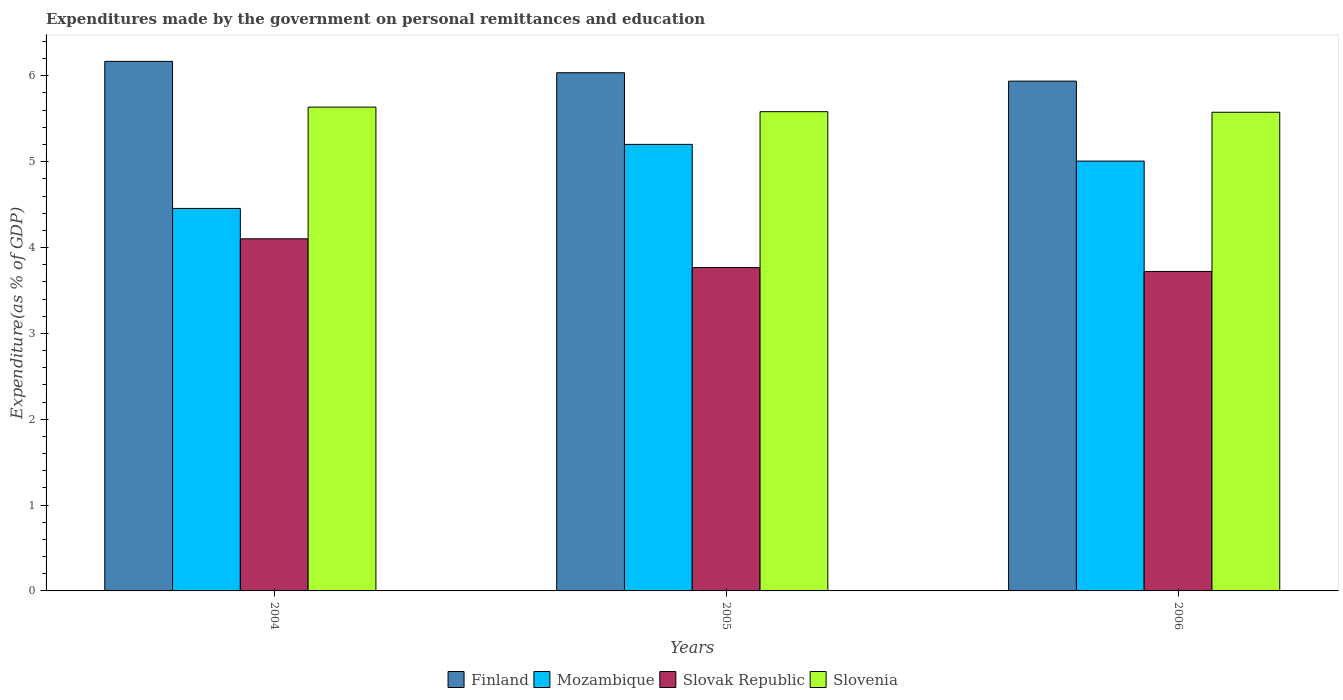How many groups of bars are there?
Your answer should be very brief. 3. How many bars are there on the 2nd tick from the right?
Ensure brevity in your answer.  4. What is the label of the 2nd group of bars from the left?
Give a very brief answer. 2005. In how many cases, is the number of bars for a given year not equal to the number of legend labels?
Provide a succinct answer. 0. What is the expenditures made by the government on personal remittances and education in Mozambique in 2006?
Offer a very short reply. 5.01. Across all years, what is the maximum expenditures made by the government on personal remittances and education in Slovak Republic?
Ensure brevity in your answer.  4.1. Across all years, what is the minimum expenditures made by the government on personal remittances and education in Mozambique?
Provide a short and direct response. 4.46. In which year was the expenditures made by the government on personal remittances and education in Slovak Republic maximum?
Provide a short and direct response. 2004. In which year was the expenditures made by the government on personal remittances and education in Finland minimum?
Ensure brevity in your answer.  2006. What is the total expenditures made by the government on personal remittances and education in Slovak Republic in the graph?
Keep it short and to the point. 11.59. What is the difference between the expenditures made by the government on personal remittances and education in Finland in 2004 and that in 2005?
Ensure brevity in your answer.  0.13. What is the difference between the expenditures made by the government on personal remittances and education in Slovenia in 2006 and the expenditures made by the government on personal remittances and education in Finland in 2004?
Provide a short and direct response. -0.59. What is the average expenditures made by the government on personal remittances and education in Finland per year?
Give a very brief answer. 6.05. In the year 2005, what is the difference between the expenditures made by the government on personal remittances and education in Slovenia and expenditures made by the government on personal remittances and education in Slovak Republic?
Give a very brief answer. 1.82. What is the ratio of the expenditures made by the government on personal remittances and education in Slovenia in 2004 to that in 2005?
Provide a succinct answer. 1.01. Is the difference between the expenditures made by the government on personal remittances and education in Slovenia in 2004 and 2006 greater than the difference between the expenditures made by the government on personal remittances and education in Slovak Republic in 2004 and 2006?
Offer a very short reply. No. What is the difference between the highest and the second highest expenditures made by the government on personal remittances and education in Mozambique?
Keep it short and to the point. 0.19. What is the difference between the highest and the lowest expenditures made by the government on personal remittances and education in Finland?
Provide a short and direct response. 0.23. Is the sum of the expenditures made by the government on personal remittances and education in Finland in 2004 and 2006 greater than the maximum expenditures made by the government on personal remittances and education in Slovenia across all years?
Your response must be concise. Yes. Is it the case that in every year, the sum of the expenditures made by the government on personal remittances and education in Finland and expenditures made by the government on personal remittances and education in Mozambique is greater than the sum of expenditures made by the government on personal remittances and education in Slovak Republic and expenditures made by the government on personal remittances and education in Slovenia?
Ensure brevity in your answer.  Yes. What does the 1st bar from the left in 2004 represents?
Provide a short and direct response. Finland. What does the 2nd bar from the right in 2004 represents?
Give a very brief answer. Slovak Republic. Is it the case that in every year, the sum of the expenditures made by the government on personal remittances and education in Mozambique and expenditures made by the government on personal remittances and education in Slovenia is greater than the expenditures made by the government on personal remittances and education in Finland?
Ensure brevity in your answer.  Yes. Are all the bars in the graph horizontal?
Your answer should be very brief. No. What is the difference between two consecutive major ticks on the Y-axis?
Make the answer very short. 1. How many legend labels are there?
Provide a short and direct response. 4. What is the title of the graph?
Provide a succinct answer. Expenditures made by the government on personal remittances and education. What is the label or title of the Y-axis?
Offer a very short reply. Expenditure(as % of GDP). What is the Expenditure(as % of GDP) of Finland in 2004?
Ensure brevity in your answer.  6.17. What is the Expenditure(as % of GDP) of Mozambique in 2004?
Your response must be concise. 4.46. What is the Expenditure(as % of GDP) in Slovak Republic in 2004?
Your answer should be very brief. 4.1. What is the Expenditure(as % of GDP) of Slovenia in 2004?
Offer a very short reply. 5.64. What is the Expenditure(as % of GDP) of Finland in 2005?
Provide a succinct answer. 6.04. What is the Expenditure(as % of GDP) of Mozambique in 2005?
Your answer should be very brief. 5.2. What is the Expenditure(as % of GDP) of Slovak Republic in 2005?
Your response must be concise. 3.77. What is the Expenditure(as % of GDP) in Slovenia in 2005?
Offer a terse response. 5.58. What is the Expenditure(as % of GDP) in Finland in 2006?
Keep it short and to the point. 5.94. What is the Expenditure(as % of GDP) of Mozambique in 2006?
Offer a terse response. 5.01. What is the Expenditure(as % of GDP) of Slovak Republic in 2006?
Offer a very short reply. 3.72. What is the Expenditure(as % of GDP) in Slovenia in 2006?
Ensure brevity in your answer.  5.58. Across all years, what is the maximum Expenditure(as % of GDP) of Finland?
Provide a succinct answer. 6.17. Across all years, what is the maximum Expenditure(as % of GDP) in Mozambique?
Provide a succinct answer. 5.2. Across all years, what is the maximum Expenditure(as % of GDP) in Slovak Republic?
Keep it short and to the point. 4.1. Across all years, what is the maximum Expenditure(as % of GDP) in Slovenia?
Offer a very short reply. 5.64. Across all years, what is the minimum Expenditure(as % of GDP) in Finland?
Provide a succinct answer. 5.94. Across all years, what is the minimum Expenditure(as % of GDP) of Mozambique?
Give a very brief answer. 4.46. Across all years, what is the minimum Expenditure(as % of GDP) in Slovak Republic?
Keep it short and to the point. 3.72. Across all years, what is the minimum Expenditure(as % of GDP) of Slovenia?
Ensure brevity in your answer.  5.58. What is the total Expenditure(as % of GDP) in Finland in the graph?
Keep it short and to the point. 18.14. What is the total Expenditure(as % of GDP) of Mozambique in the graph?
Give a very brief answer. 14.66. What is the total Expenditure(as % of GDP) of Slovak Republic in the graph?
Keep it short and to the point. 11.59. What is the total Expenditure(as % of GDP) of Slovenia in the graph?
Give a very brief answer. 16.79. What is the difference between the Expenditure(as % of GDP) of Finland in 2004 and that in 2005?
Your answer should be compact. 0.13. What is the difference between the Expenditure(as % of GDP) of Mozambique in 2004 and that in 2005?
Make the answer very short. -0.75. What is the difference between the Expenditure(as % of GDP) of Slovak Republic in 2004 and that in 2005?
Your answer should be very brief. 0.34. What is the difference between the Expenditure(as % of GDP) of Slovenia in 2004 and that in 2005?
Make the answer very short. 0.05. What is the difference between the Expenditure(as % of GDP) in Finland in 2004 and that in 2006?
Keep it short and to the point. 0.23. What is the difference between the Expenditure(as % of GDP) of Mozambique in 2004 and that in 2006?
Provide a short and direct response. -0.55. What is the difference between the Expenditure(as % of GDP) of Slovak Republic in 2004 and that in 2006?
Make the answer very short. 0.38. What is the difference between the Expenditure(as % of GDP) of Slovenia in 2004 and that in 2006?
Provide a succinct answer. 0.06. What is the difference between the Expenditure(as % of GDP) in Finland in 2005 and that in 2006?
Offer a very short reply. 0.1. What is the difference between the Expenditure(as % of GDP) of Mozambique in 2005 and that in 2006?
Provide a succinct answer. 0.19. What is the difference between the Expenditure(as % of GDP) of Slovak Republic in 2005 and that in 2006?
Your answer should be compact. 0.05. What is the difference between the Expenditure(as % of GDP) in Slovenia in 2005 and that in 2006?
Make the answer very short. 0.01. What is the difference between the Expenditure(as % of GDP) in Finland in 2004 and the Expenditure(as % of GDP) in Mozambique in 2005?
Offer a very short reply. 0.97. What is the difference between the Expenditure(as % of GDP) in Finland in 2004 and the Expenditure(as % of GDP) in Slovak Republic in 2005?
Ensure brevity in your answer.  2.4. What is the difference between the Expenditure(as % of GDP) in Finland in 2004 and the Expenditure(as % of GDP) in Slovenia in 2005?
Make the answer very short. 0.59. What is the difference between the Expenditure(as % of GDP) in Mozambique in 2004 and the Expenditure(as % of GDP) in Slovak Republic in 2005?
Make the answer very short. 0.69. What is the difference between the Expenditure(as % of GDP) of Mozambique in 2004 and the Expenditure(as % of GDP) of Slovenia in 2005?
Make the answer very short. -1.13. What is the difference between the Expenditure(as % of GDP) in Slovak Republic in 2004 and the Expenditure(as % of GDP) in Slovenia in 2005?
Make the answer very short. -1.48. What is the difference between the Expenditure(as % of GDP) of Finland in 2004 and the Expenditure(as % of GDP) of Mozambique in 2006?
Make the answer very short. 1.16. What is the difference between the Expenditure(as % of GDP) in Finland in 2004 and the Expenditure(as % of GDP) in Slovak Republic in 2006?
Ensure brevity in your answer.  2.45. What is the difference between the Expenditure(as % of GDP) in Finland in 2004 and the Expenditure(as % of GDP) in Slovenia in 2006?
Offer a very short reply. 0.59. What is the difference between the Expenditure(as % of GDP) of Mozambique in 2004 and the Expenditure(as % of GDP) of Slovak Republic in 2006?
Provide a succinct answer. 0.73. What is the difference between the Expenditure(as % of GDP) of Mozambique in 2004 and the Expenditure(as % of GDP) of Slovenia in 2006?
Offer a terse response. -1.12. What is the difference between the Expenditure(as % of GDP) in Slovak Republic in 2004 and the Expenditure(as % of GDP) in Slovenia in 2006?
Offer a terse response. -1.47. What is the difference between the Expenditure(as % of GDP) of Finland in 2005 and the Expenditure(as % of GDP) of Mozambique in 2006?
Provide a succinct answer. 1.03. What is the difference between the Expenditure(as % of GDP) of Finland in 2005 and the Expenditure(as % of GDP) of Slovak Republic in 2006?
Make the answer very short. 2.31. What is the difference between the Expenditure(as % of GDP) of Finland in 2005 and the Expenditure(as % of GDP) of Slovenia in 2006?
Keep it short and to the point. 0.46. What is the difference between the Expenditure(as % of GDP) in Mozambique in 2005 and the Expenditure(as % of GDP) in Slovak Republic in 2006?
Your answer should be compact. 1.48. What is the difference between the Expenditure(as % of GDP) in Mozambique in 2005 and the Expenditure(as % of GDP) in Slovenia in 2006?
Ensure brevity in your answer.  -0.37. What is the difference between the Expenditure(as % of GDP) in Slovak Republic in 2005 and the Expenditure(as % of GDP) in Slovenia in 2006?
Your answer should be compact. -1.81. What is the average Expenditure(as % of GDP) of Finland per year?
Your response must be concise. 6.05. What is the average Expenditure(as % of GDP) of Mozambique per year?
Your answer should be very brief. 4.89. What is the average Expenditure(as % of GDP) of Slovak Republic per year?
Your answer should be very brief. 3.86. What is the average Expenditure(as % of GDP) of Slovenia per year?
Keep it short and to the point. 5.6. In the year 2004, what is the difference between the Expenditure(as % of GDP) of Finland and Expenditure(as % of GDP) of Mozambique?
Offer a terse response. 1.71. In the year 2004, what is the difference between the Expenditure(as % of GDP) in Finland and Expenditure(as % of GDP) in Slovak Republic?
Provide a short and direct response. 2.07. In the year 2004, what is the difference between the Expenditure(as % of GDP) of Finland and Expenditure(as % of GDP) of Slovenia?
Provide a short and direct response. 0.53. In the year 2004, what is the difference between the Expenditure(as % of GDP) of Mozambique and Expenditure(as % of GDP) of Slovak Republic?
Offer a very short reply. 0.35. In the year 2004, what is the difference between the Expenditure(as % of GDP) of Mozambique and Expenditure(as % of GDP) of Slovenia?
Your answer should be compact. -1.18. In the year 2004, what is the difference between the Expenditure(as % of GDP) in Slovak Republic and Expenditure(as % of GDP) in Slovenia?
Offer a terse response. -1.53. In the year 2005, what is the difference between the Expenditure(as % of GDP) of Finland and Expenditure(as % of GDP) of Mozambique?
Provide a succinct answer. 0.83. In the year 2005, what is the difference between the Expenditure(as % of GDP) of Finland and Expenditure(as % of GDP) of Slovak Republic?
Your answer should be compact. 2.27. In the year 2005, what is the difference between the Expenditure(as % of GDP) in Finland and Expenditure(as % of GDP) in Slovenia?
Provide a succinct answer. 0.45. In the year 2005, what is the difference between the Expenditure(as % of GDP) in Mozambique and Expenditure(as % of GDP) in Slovak Republic?
Offer a terse response. 1.43. In the year 2005, what is the difference between the Expenditure(as % of GDP) in Mozambique and Expenditure(as % of GDP) in Slovenia?
Offer a very short reply. -0.38. In the year 2005, what is the difference between the Expenditure(as % of GDP) in Slovak Republic and Expenditure(as % of GDP) in Slovenia?
Your answer should be compact. -1.82. In the year 2006, what is the difference between the Expenditure(as % of GDP) in Finland and Expenditure(as % of GDP) in Mozambique?
Offer a terse response. 0.93. In the year 2006, what is the difference between the Expenditure(as % of GDP) in Finland and Expenditure(as % of GDP) in Slovak Republic?
Offer a terse response. 2.22. In the year 2006, what is the difference between the Expenditure(as % of GDP) of Finland and Expenditure(as % of GDP) of Slovenia?
Give a very brief answer. 0.36. In the year 2006, what is the difference between the Expenditure(as % of GDP) in Mozambique and Expenditure(as % of GDP) in Slovak Republic?
Your response must be concise. 1.29. In the year 2006, what is the difference between the Expenditure(as % of GDP) of Mozambique and Expenditure(as % of GDP) of Slovenia?
Provide a short and direct response. -0.57. In the year 2006, what is the difference between the Expenditure(as % of GDP) in Slovak Republic and Expenditure(as % of GDP) in Slovenia?
Offer a very short reply. -1.85. What is the ratio of the Expenditure(as % of GDP) in Finland in 2004 to that in 2005?
Offer a very short reply. 1.02. What is the ratio of the Expenditure(as % of GDP) in Mozambique in 2004 to that in 2005?
Your response must be concise. 0.86. What is the ratio of the Expenditure(as % of GDP) in Slovak Republic in 2004 to that in 2005?
Your response must be concise. 1.09. What is the ratio of the Expenditure(as % of GDP) in Slovenia in 2004 to that in 2005?
Ensure brevity in your answer.  1.01. What is the ratio of the Expenditure(as % of GDP) in Finland in 2004 to that in 2006?
Offer a very short reply. 1.04. What is the ratio of the Expenditure(as % of GDP) in Mozambique in 2004 to that in 2006?
Your response must be concise. 0.89. What is the ratio of the Expenditure(as % of GDP) of Slovak Republic in 2004 to that in 2006?
Your answer should be compact. 1.1. What is the ratio of the Expenditure(as % of GDP) of Slovenia in 2004 to that in 2006?
Offer a very short reply. 1.01. What is the ratio of the Expenditure(as % of GDP) of Finland in 2005 to that in 2006?
Your answer should be very brief. 1.02. What is the ratio of the Expenditure(as % of GDP) in Mozambique in 2005 to that in 2006?
Provide a succinct answer. 1.04. What is the ratio of the Expenditure(as % of GDP) in Slovak Republic in 2005 to that in 2006?
Offer a very short reply. 1.01. What is the difference between the highest and the second highest Expenditure(as % of GDP) in Finland?
Ensure brevity in your answer.  0.13. What is the difference between the highest and the second highest Expenditure(as % of GDP) of Mozambique?
Ensure brevity in your answer.  0.19. What is the difference between the highest and the second highest Expenditure(as % of GDP) in Slovak Republic?
Make the answer very short. 0.34. What is the difference between the highest and the second highest Expenditure(as % of GDP) of Slovenia?
Provide a short and direct response. 0.05. What is the difference between the highest and the lowest Expenditure(as % of GDP) in Finland?
Your answer should be very brief. 0.23. What is the difference between the highest and the lowest Expenditure(as % of GDP) of Mozambique?
Your answer should be very brief. 0.75. What is the difference between the highest and the lowest Expenditure(as % of GDP) in Slovak Republic?
Keep it short and to the point. 0.38. What is the difference between the highest and the lowest Expenditure(as % of GDP) in Slovenia?
Keep it short and to the point. 0.06. 